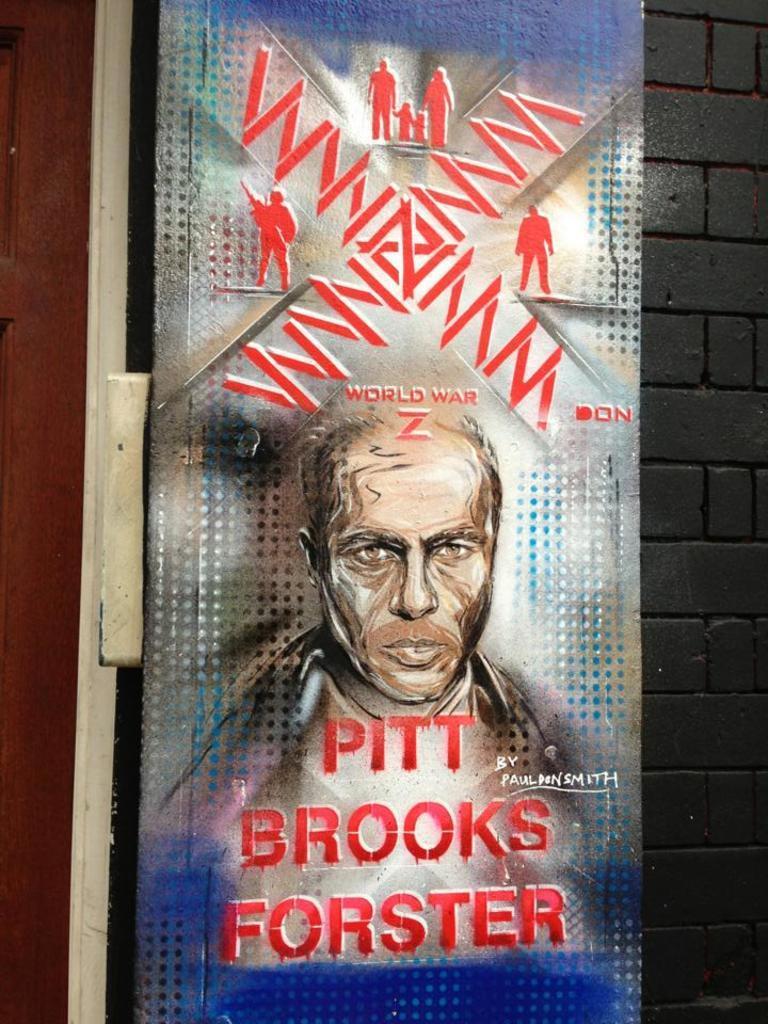How would you summarize this image in a sentence or two? In this picture I can see there is a poster and there is a painting of a man and there is something written on it. There are a few more pictures on it and there is a brick wall at the right side. 